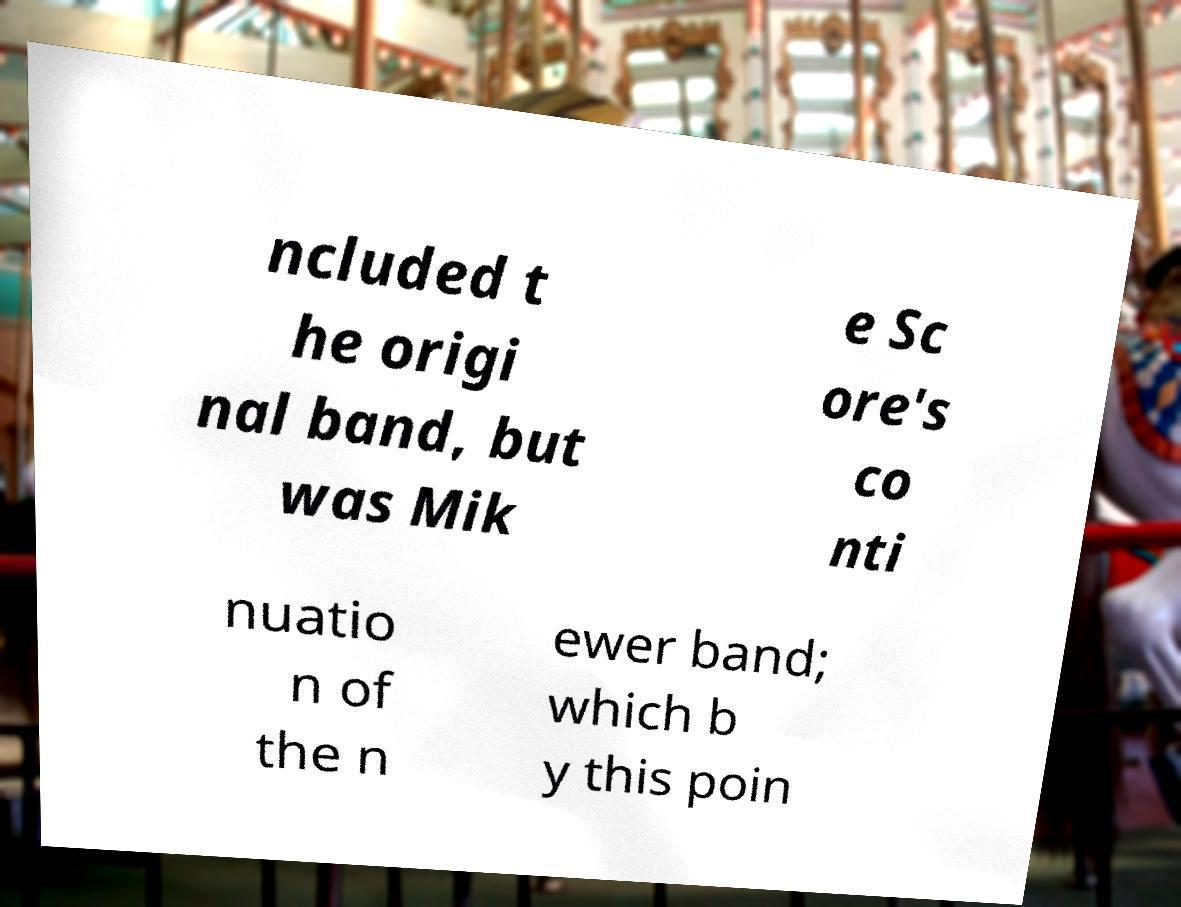Please identify and transcribe the text found in this image. ncluded t he origi nal band, but was Mik e Sc ore's co nti nuatio n of the n ewer band; which b y this poin 